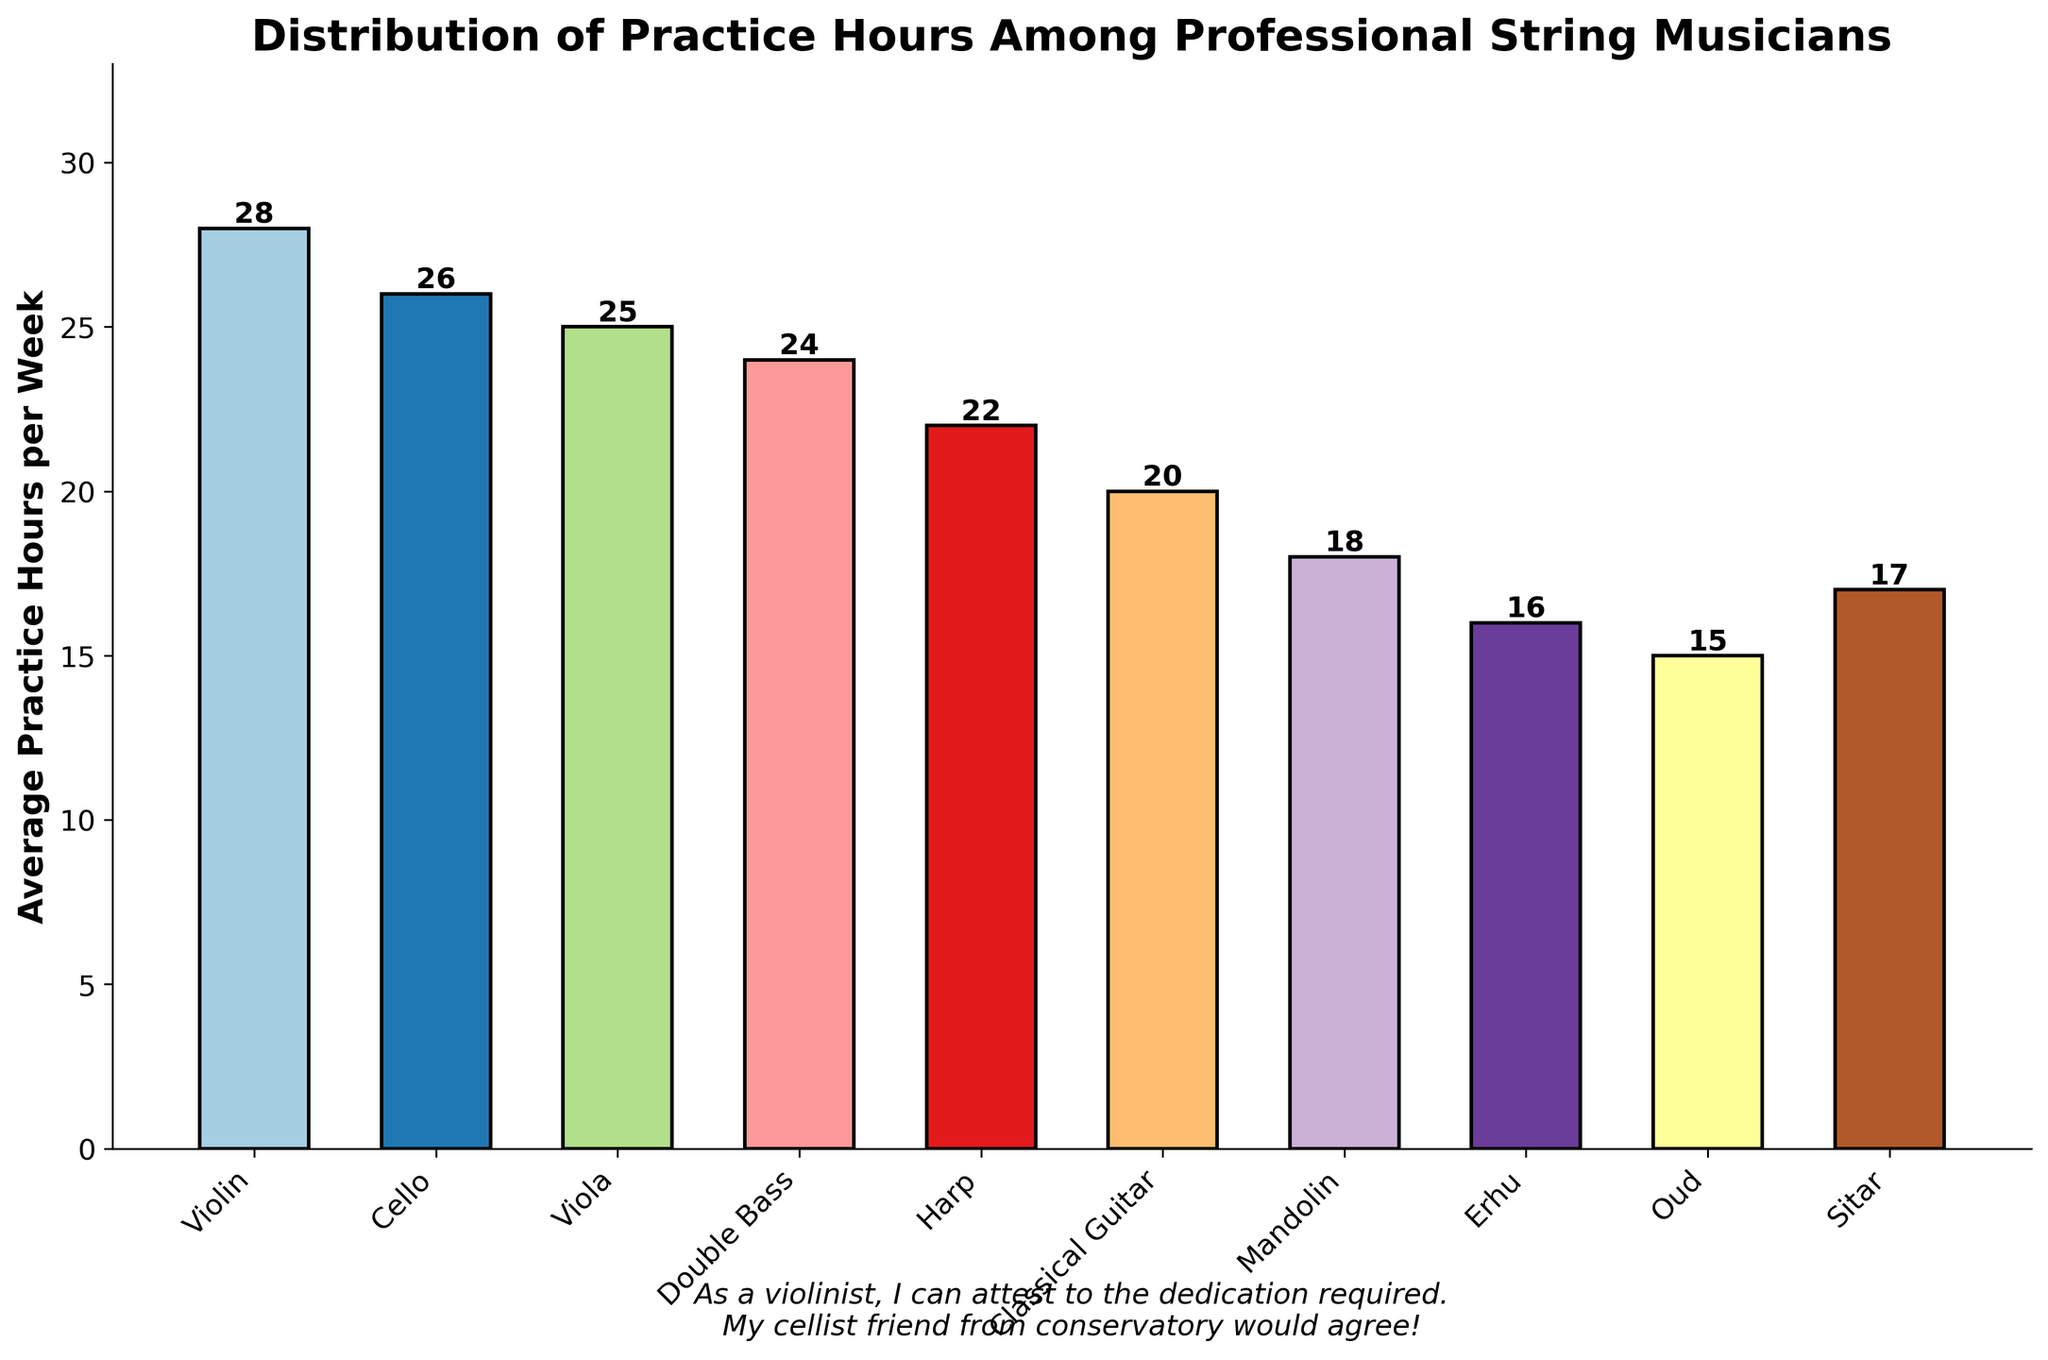Which instrument has the highest average practice hours per week? The bar representing the violin is the tallest, indicating the highest average practice hours per week.
Answer: Violin Which instrument practices the least on average per week? The bar for the Oud is the shortest, indicating the fewest average practice hours per week.
Answer: Oud What is the difference in average practice hours per week between the Violin and the Oud? The Violin has 28 hours and the Oud has 15 hours. The difference is 28 - 15.
Answer: 13 What is the total of the average practice hours per week for Violin, Cello, and Viola combined? Sum the hours for Violin (28), Cello (26), and Viola (25), i.e., 28 + 26 + 25.
Answer: 79 Which instruments practice more than 20 hours on average per week? Identify the bars extending above the 20-hour mark. Violin, Cello, Viola, Double Bass, Harp.
Answer: Violin, Cello, Viola, Double Bass, Harp How much more does a Violinist practice compared to a Harpist on average per week? The average practice hours per week for Violin is 28 and for Harp is 22. The difference is 28 - 22.
Answer: 6 What is the average practice hours per week for Sitar and Mandolin combined? The Sitar practices 17 hours and the Mandolin practices 18 hours. Calculate the average: (17 + 18) / 2.
Answer: 17.5 What is the difference in average practice hours per week between the Cello and the Double Bass? Cello practices 26 hours and Double Bass practices 24 hours. The difference is 26 - 24.
Answer: 2 Among the Harp, Classical Guitar, Mandolin, and Erhu, which practices the most per week? Compare the bar heights for Harp (22), Classical Guitar (20), Mandolin (18), and Erhu (16). The Harp has the highest bar.
Answer: Harp Which instrument, between the Oud and Sitar, practices less on average per week? The Oud practices 15 hours while the Sitar practices 17 hours.
Answer: Oud 